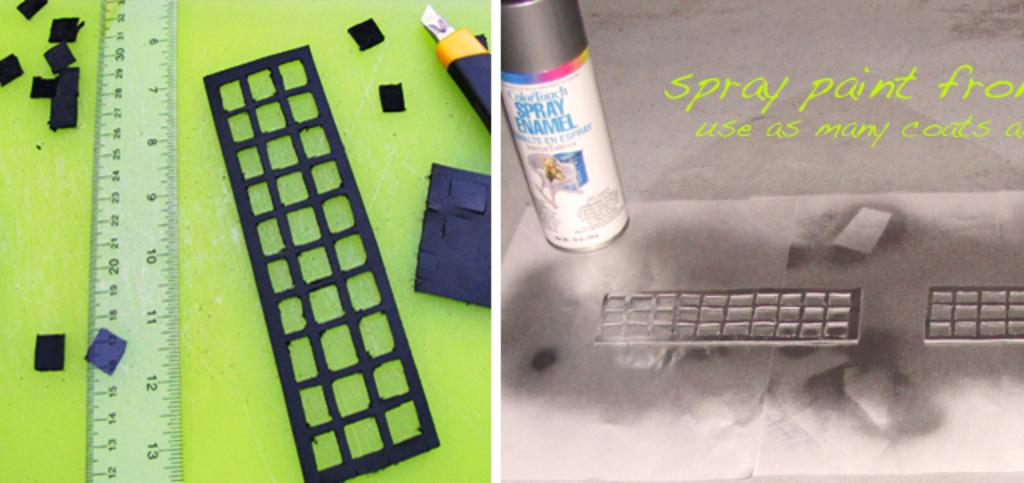<image>
Relay a brief, clear account of the picture shown. A green ruler that measures in inches and centimeters on the left and a spray enamel branded can of paint on the right. 